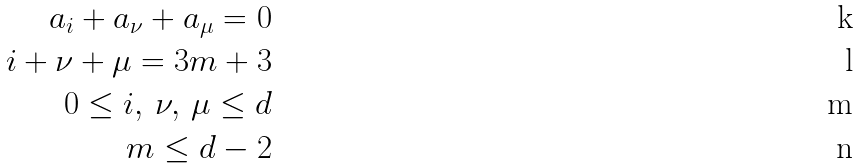Convert formula to latex. <formula><loc_0><loc_0><loc_500><loc_500>a _ { i } + a _ { \nu } + a _ { \mu } = 0 \\ i + \nu + \mu = 3 m + 3 \\ 0 \leq i , \, \nu , \, \mu \leq d \\ m \leq d - 2</formula> 